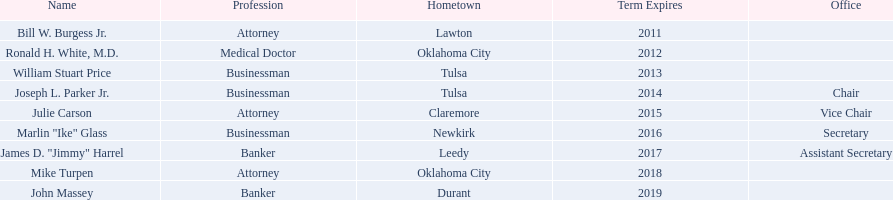What are the names of all the members? Bill W. Burgess Jr., Ronald H. White, M.D., William Stuart Price, Joseph L. Parker Jr., Julie Carson, Marlin "Ike" Glass, James D. "Jimmy" Harrel, Mike Turpen, John Massey. Where does each individual come from? Lawton, Oklahoma City, Tulsa, Tulsa, Claremore, Newkirk, Leedy, Oklahoma City, Durant. Besides joseph l. parker jr., who else hails from tulsa? William Stuart Price. 